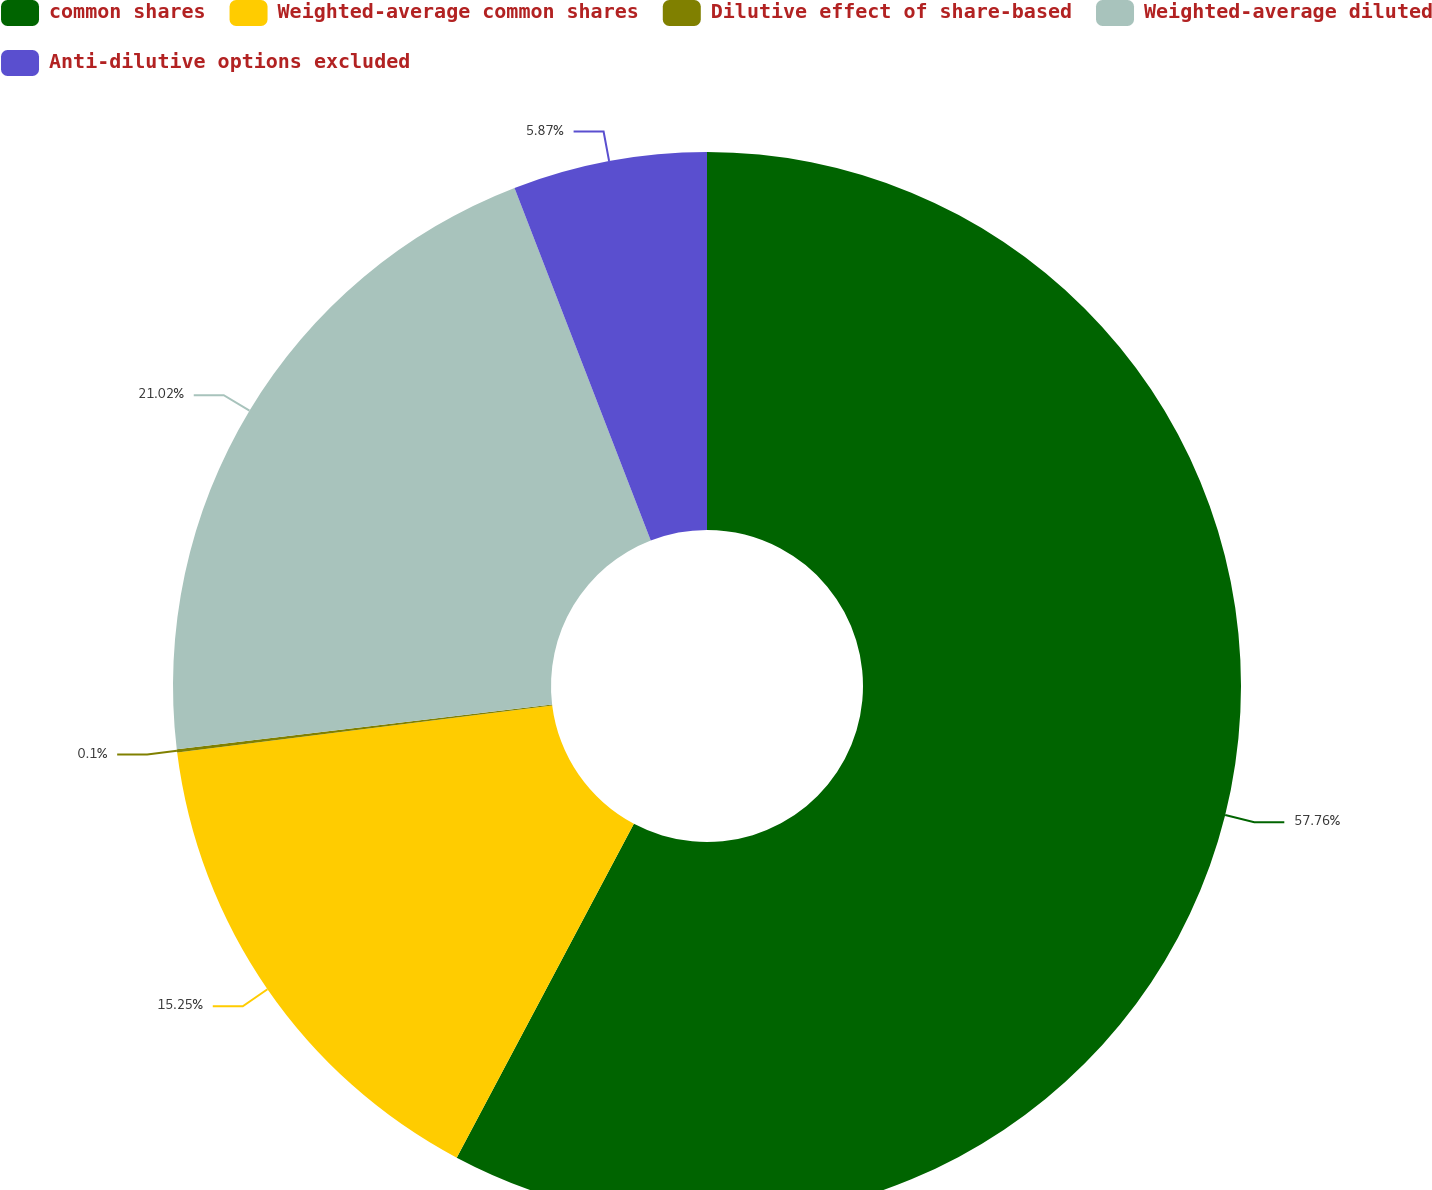Convert chart. <chart><loc_0><loc_0><loc_500><loc_500><pie_chart><fcel>common shares<fcel>Weighted-average common shares<fcel>Dilutive effect of share-based<fcel>Weighted-average diluted<fcel>Anti-dilutive options excluded<nl><fcel>57.77%<fcel>15.25%<fcel>0.1%<fcel>21.02%<fcel>5.87%<nl></chart> 